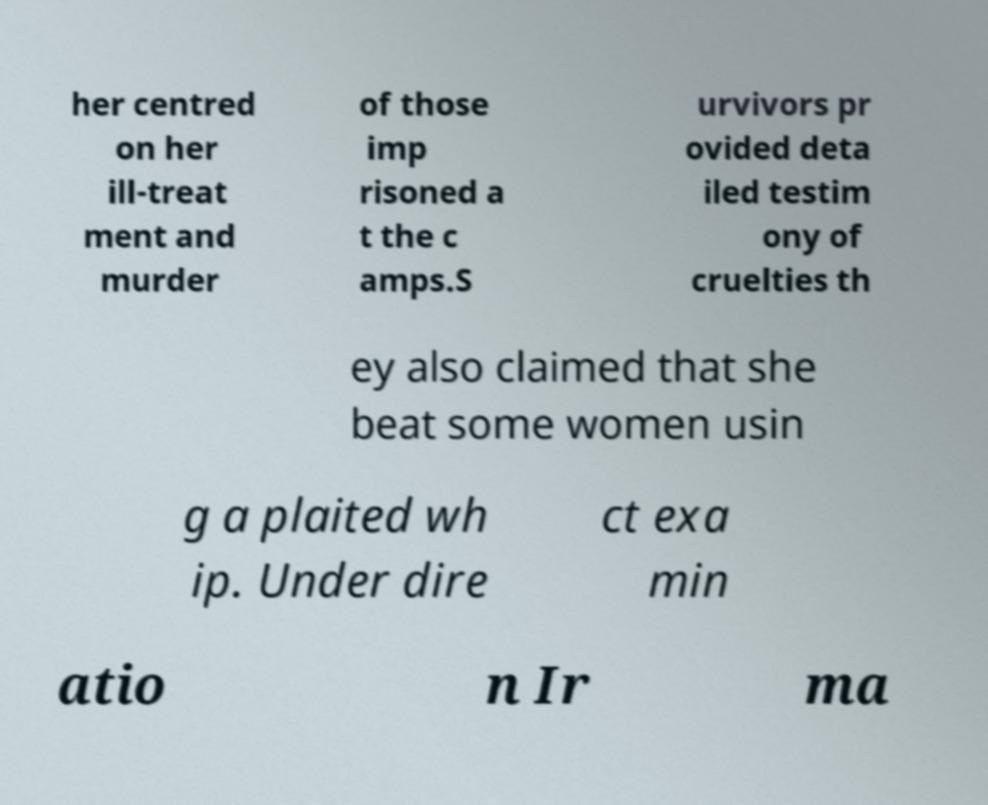Could you assist in decoding the text presented in this image and type it out clearly? her centred on her ill-treat ment and murder of those imp risoned a t the c amps.S urvivors pr ovided deta iled testim ony of cruelties th ey also claimed that she beat some women usin g a plaited wh ip. Under dire ct exa min atio n Ir ma 